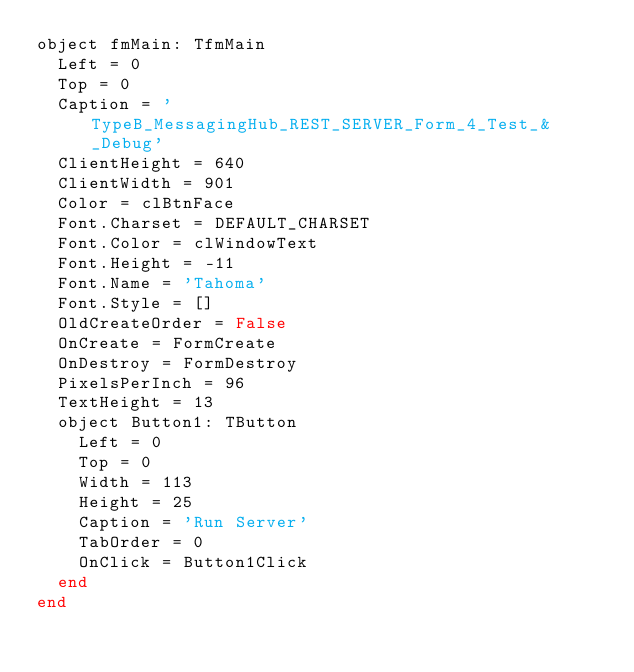<code> <loc_0><loc_0><loc_500><loc_500><_Pascal_>object fmMain: TfmMain
  Left = 0
  Top = 0
  Caption = 'TypeB_MessagingHub_REST_SERVER_Form_4_Test_&_Debug'
  ClientHeight = 640
  ClientWidth = 901
  Color = clBtnFace
  Font.Charset = DEFAULT_CHARSET
  Font.Color = clWindowText
  Font.Height = -11
  Font.Name = 'Tahoma'
  Font.Style = []
  OldCreateOrder = False
  OnCreate = FormCreate
  OnDestroy = FormDestroy
  PixelsPerInch = 96
  TextHeight = 13
  object Button1: TButton
    Left = 0
    Top = 0
    Width = 113
    Height = 25
    Caption = 'Run Server'
    TabOrder = 0
    OnClick = Button1Click
  end
end
</code> 